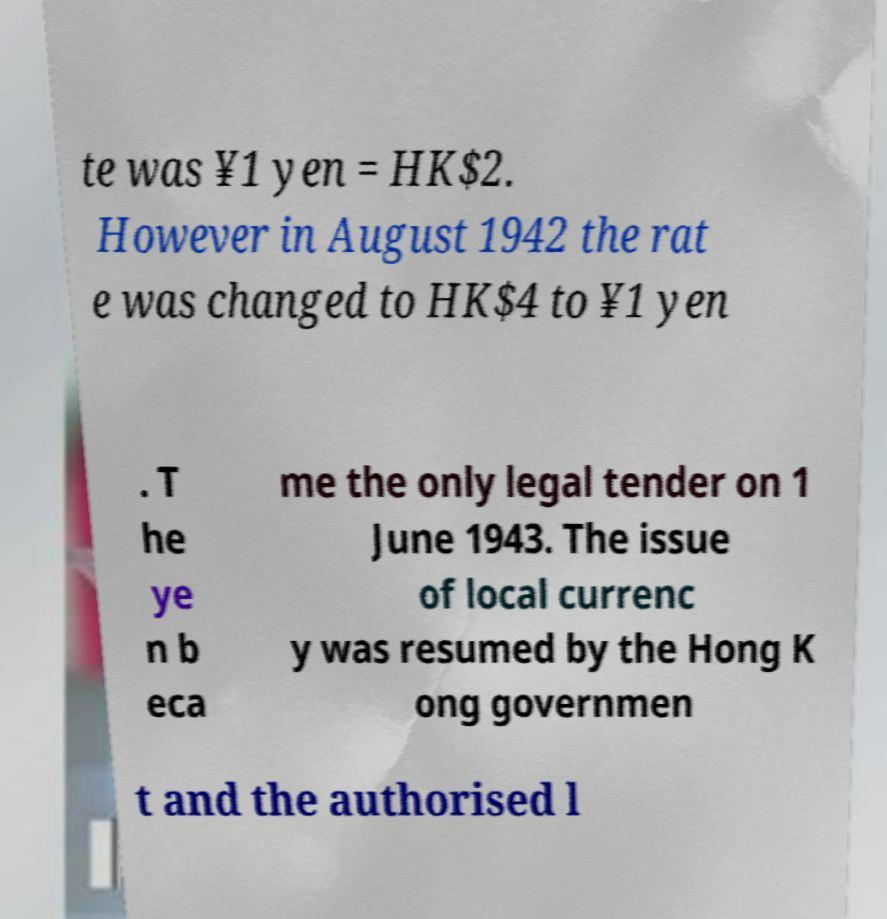What messages or text are displayed in this image? I need them in a readable, typed format. te was ¥1 yen = HK$2. However in August 1942 the rat e was changed to HK$4 to ¥1 yen . T he ye n b eca me the only legal tender on 1 June 1943. The issue of local currenc y was resumed by the Hong K ong governmen t and the authorised l 